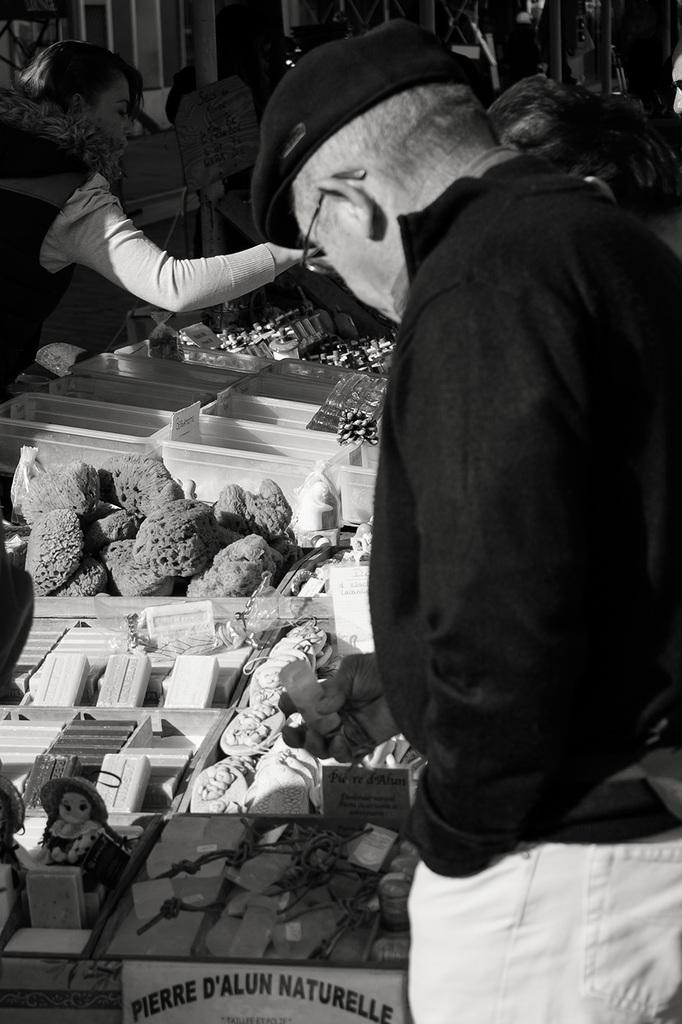Who or what can be seen in the image? There are people in the image. What type of structure is present in the image? There is a stall in the image. What else can be found in the image besides people and the stall? There are objects, boxes, and dolls in the image. What type of texture can be seen on the apples in the image? There are no apples present in the image, so it is not possible to determine the texture of any apples. 